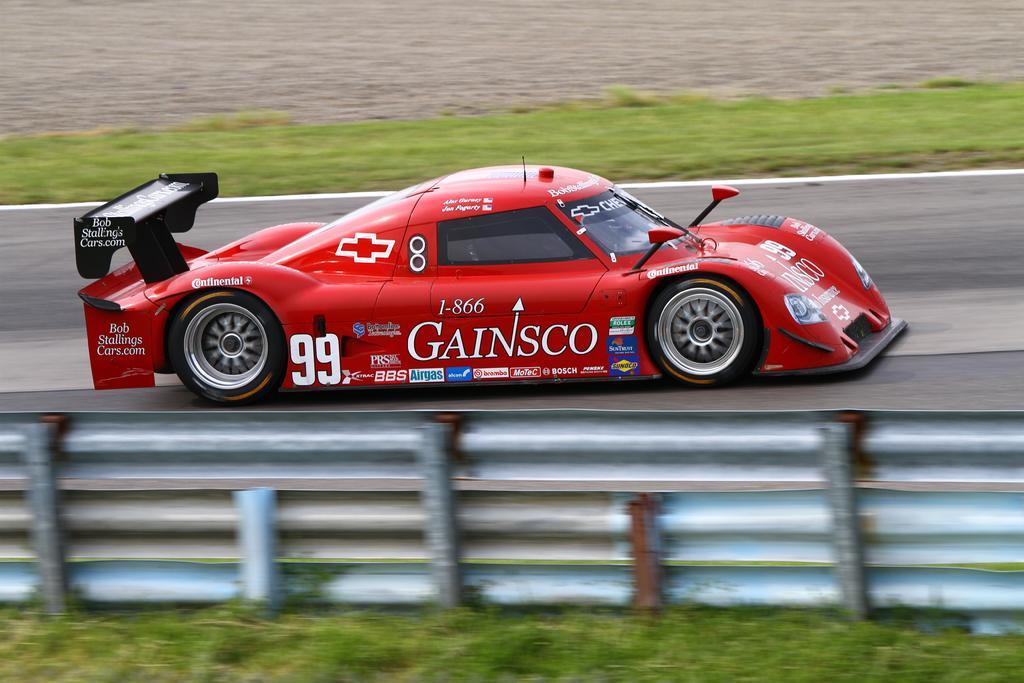Describe this image in one or two sentences. In this picture we can see a fence and a vehicle on the road and in the background we can see grass on the ground. 